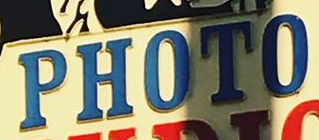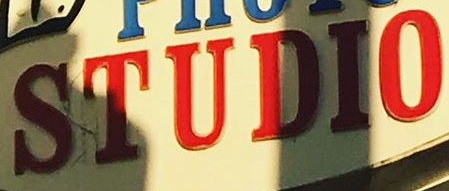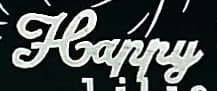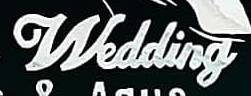What text is displayed in these images sequentially, separated by a semicolon? PHOTO; STUDIO; Happy; Wedding 